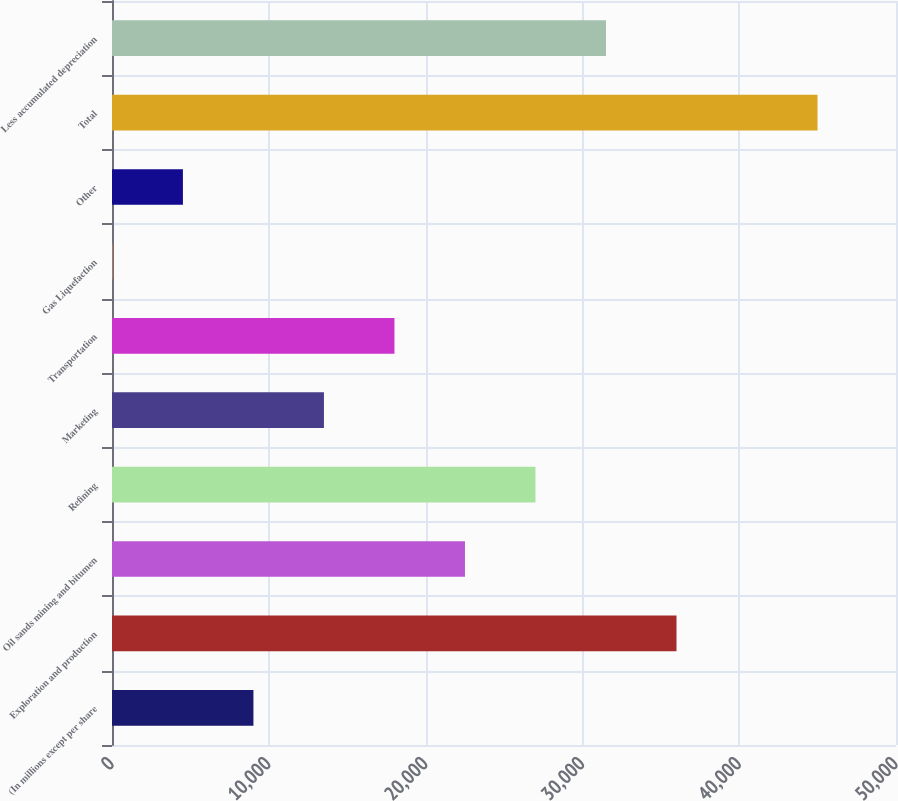Convert chart. <chart><loc_0><loc_0><loc_500><loc_500><bar_chart><fcel>(In millions except per share<fcel>Exploration and production<fcel>Oil sands mining and bitumen<fcel>Refining<fcel>Marketing<fcel>Transportation<fcel>Gas Liquefaction<fcel>Other<fcel>Total<fcel>Less accumulated depreciation<nl><fcel>9019.8<fcel>36001.2<fcel>22510.5<fcel>27007.4<fcel>13516.7<fcel>18013.6<fcel>26<fcel>4522.9<fcel>44995<fcel>31504.3<nl></chart> 